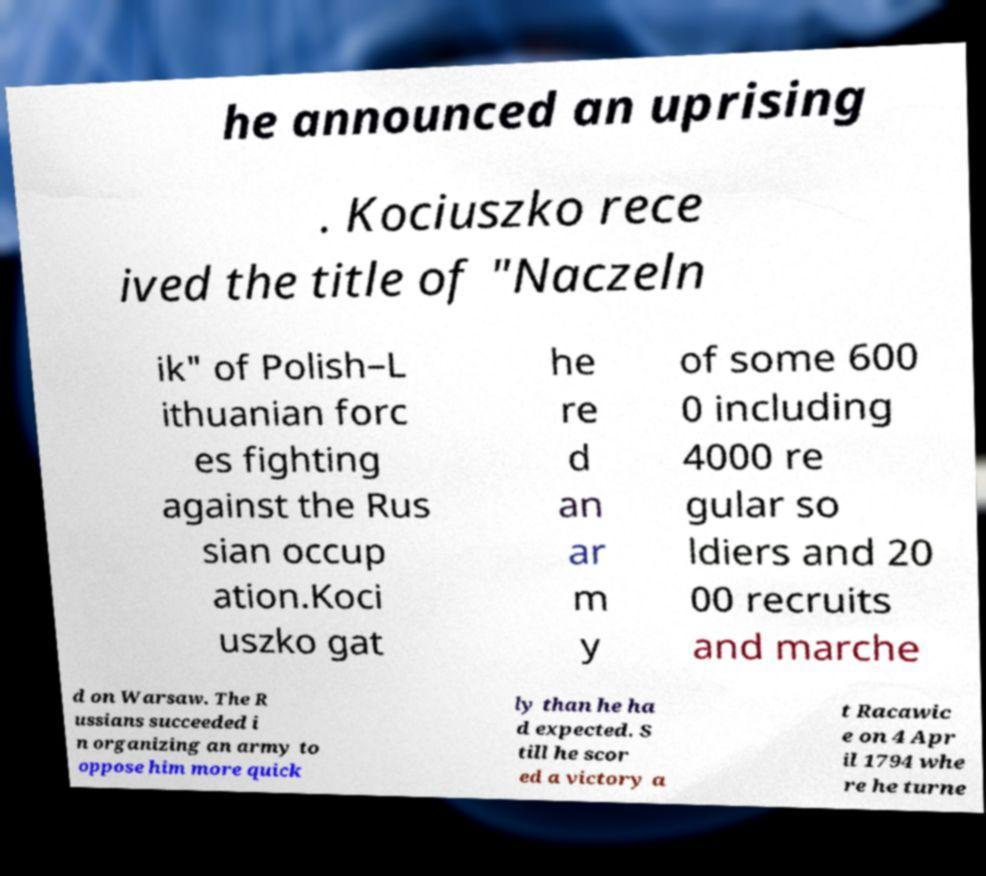Can you accurately transcribe the text from the provided image for me? he announced an uprising . Kociuszko rece ived the title of "Naczeln ik" of Polish–L ithuanian forc es fighting against the Rus sian occup ation.Koci uszko gat he re d an ar m y of some 600 0 including 4000 re gular so ldiers and 20 00 recruits and marche d on Warsaw. The R ussians succeeded i n organizing an army to oppose him more quick ly than he ha d expected. S till he scor ed a victory a t Racawic e on 4 Apr il 1794 whe re he turne 